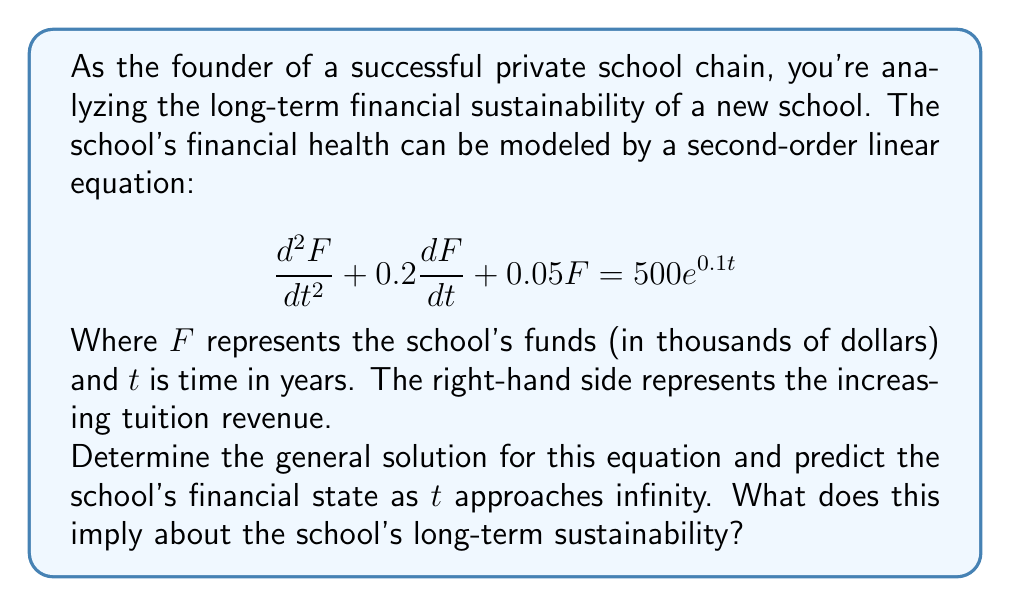Can you solve this math problem? Let's solve this step-by-step:

1) The general form of a second-order linear differential equation is:
   $$a\frac{d^2y}{dx^2} + b\frac{dy}{dx} + cy = f(x)$$

2) In our case, $a=1$, $b=0.2$, $c=0.05$, and $f(t) = 500e^{0.1t}$

3) The complementary solution $F_c$ is found by solving the characteristic equation:
   $$r^2 + 0.2r + 0.05 = 0$$

4) Using the quadratic formula, we get:
   $$r = \frac{-0.2 \pm \sqrt{0.2^2 - 4(1)(0.05)}}{2(1)} = -0.1 \pm 0.1i$$

5) Therefore, the complementary solution is:
   $$F_c = e^{-0.1t}(A\cos(0.1t) + B\sin(0.1t))$$

6) For the particular solution $F_p$, we assume a form:
   $$F_p = Ce^{0.1t}$$

7) Substituting this into the original equation:
   $$C(0.01 + 0.02 + 0.05)e^{0.1t} = 500e^{0.1t}$$
   $$0.08C = 500$$
   $$C = 6250$$

8) Therefore, the particular solution is:
   $$F_p = 6250e^{0.1t}$$

9) The general solution is the sum of $F_c$ and $F_p$:
   $$F = e^{-0.1t}(A\cos(0.1t) + B\sin(0.1t)) + 6250e^{0.1t}$$

10) As $t$ approaches infinity, the term $e^{-0.1t}$ approaches zero, while $6250e^{0.1t}$ grows exponentially.

This implies that in the long term, the school's funds will grow exponentially, indicating strong financial sustainability.
Answer: $F = e^{-0.1t}(A\cos(0.1t) + B\sin(0.1t)) + 6250e^{0.1t}$; exponential growth as $t \to \infty$ 